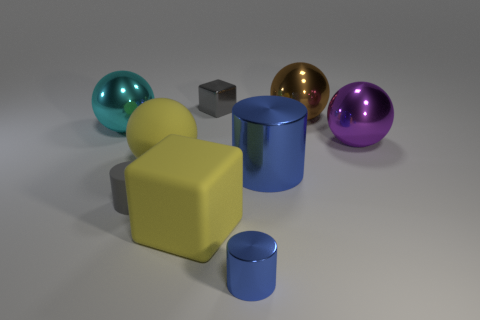Add 1 matte balls. How many objects exist? 10 Subtract all cylinders. How many objects are left? 6 Subtract all yellow matte balls. Subtract all big metallic balls. How many objects are left? 5 Add 1 yellow matte things. How many yellow matte things are left? 3 Add 1 gray things. How many gray things exist? 3 Subtract 0 blue cubes. How many objects are left? 9 